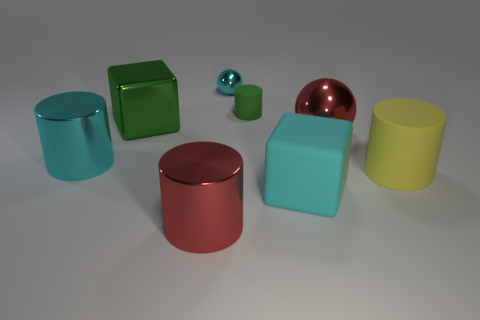There is a cylinder that is the same color as the large metallic sphere; what is it made of?
Your answer should be very brief. Metal. What number of big objects are either brown metallic cylinders or cyan rubber blocks?
Offer a terse response. 1. Is the number of cyan things less than the number of big objects?
Keep it short and to the point. Yes. Are there any other things that are the same size as the cyan cylinder?
Provide a succinct answer. Yes. Does the small metal sphere have the same color as the big rubber cube?
Your response must be concise. Yes. Is the number of green blocks greater than the number of red cubes?
Offer a terse response. Yes. What number of other objects are the same color as the big metallic ball?
Make the answer very short. 1. There is a cyan thing on the left side of the large green block; how many red metal balls are in front of it?
Your answer should be very brief. 0. There is a green metallic cube; are there any red things on the left side of it?
Your answer should be compact. No. There is a large red thing on the left side of the red shiny object that is to the right of the small sphere; what is its shape?
Ensure brevity in your answer.  Cylinder. 